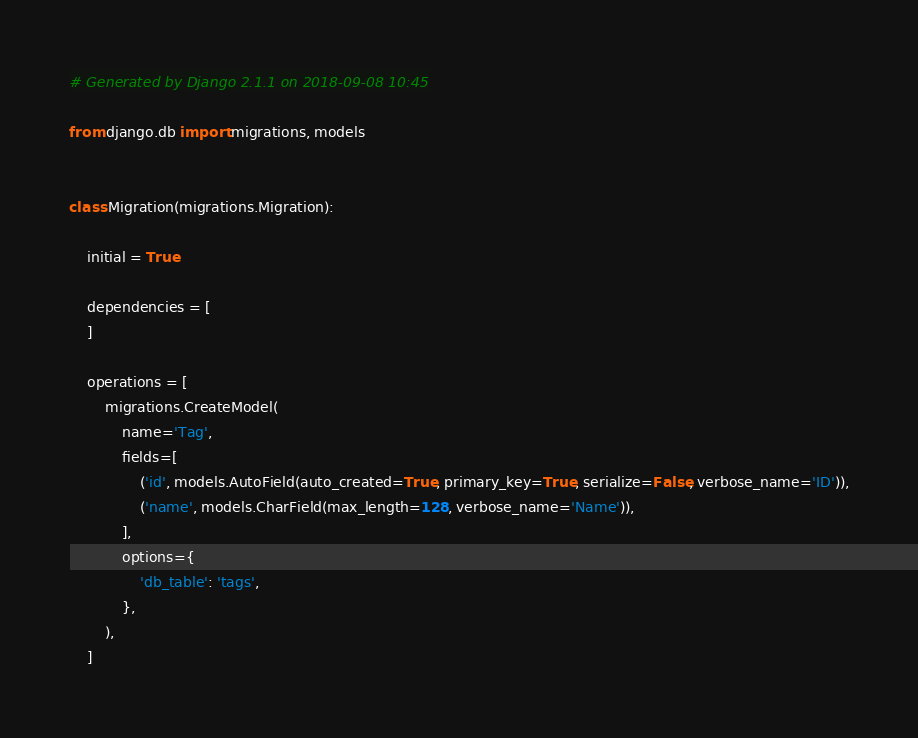<code> <loc_0><loc_0><loc_500><loc_500><_Python_># Generated by Django 2.1.1 on 2018-09-08 10:45

from django.db import migrations, models


class Migration(migrations.Migration):

    initial = True

    dependencies = [
    ]

    operations = [
        migrations.CreateModel(
            name='Tag',
            fields=[
                ('id', models.AutoField(auto_created=True, primary_key=True, serialize=False, verbose_name='ID')),
                ('name', models.CharField(max_length=128, verbose_name='Name')),
            ],
            options={
                'db_table': 'tags',
            },
        ),
    ]
</code> 